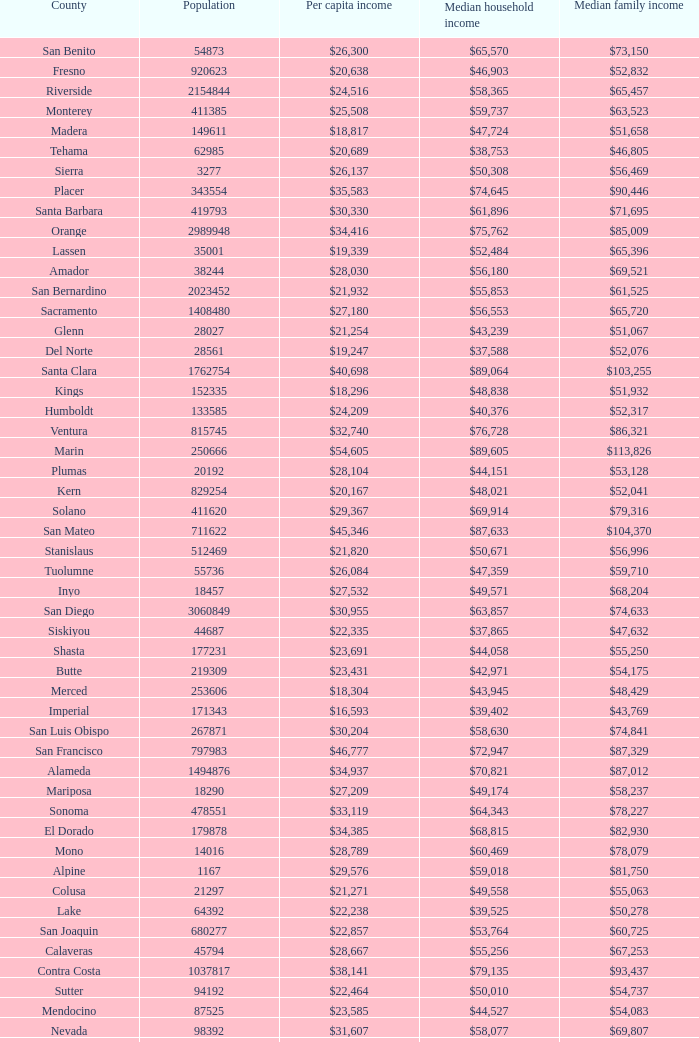Name the median family income for riverside $65,457. 